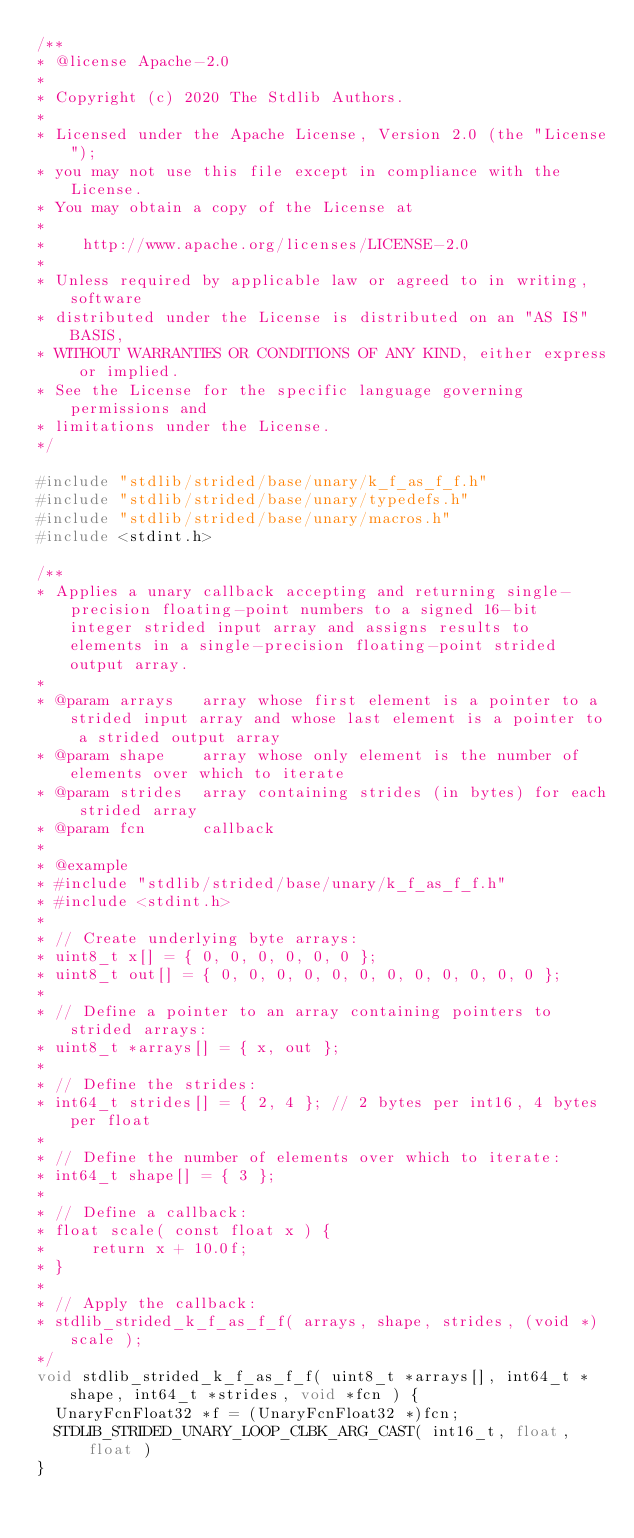<code> <loc_0><loc_0><loc_500><loc_500><_C_>/**
* @license Apache-2.0
*
* Copyright (c) 2020 The Stdlib Authors.
*
* Licensed under the Apache License, Version 2.0 (the "License");
* you may not use this file except in compliance with the License.
* You may obtain a copy of the License at
*
*    http://www.apache.org/licenses/LICENSE-2.0
*
* Unless required by applicable law or agreed to in writing, software
* distributed under the License is distributed on an "AS IS" BASIS,
* WITHOUT WARRANTIES OR CONDITIONS OF ANY KIND, either express or implied.
* See the License for the specific language governing permissions and
* limitations under the License.
*/

#include "stdlib/strided/base/unary/k_f_as_f_f.h"
#include "stdlib/strided/base/unary/typedefs.h"
#include "stdlib/strided/base/unary/macros.h"
#include <stdint.h>

/**
* Applies a unary callback accepting and returning single-precision floating-point numbers to a signed 16-bit integer strided input array and assigns results to elements in a single-precision floating-point strided output array.
*
* @param arrays   array whose first element is a pointer to a strided input array and whose last element is a pointer to a strided output array
* @param shape    array whose only element is the number of elements over which to iterate
* @param strides  array containing strides (in bytes) for each strided array
* @param fcn      callback
*
* @example
* #include "stdlib/strided/base/unary/k_f_as_f_f.h"
* #include <stdint.h>
*
* // Create underlying byte arrays:
* uint8_t x[] = { 0, 0, 0, 0, 0, 0 };
* uint8_t out[] = { 0, 0, 0, 0, 0, 0, 0, 0, 0, 0, 0, 0 };
*
* // Define a pointer to an array containing pointers to strided arrays:
* uint8_t *arrays[] = { x, out };
*
* // Define the strides:
* int64_t strides[] = { 2, 4 }; // 2 bytes per int16, 4 bytes per float
*
* // Define the number of elements over which to iterate:
* int64_t shape[] = { 3 };
*
* // Define a callback:
* float scale( const float x ) {
*     return x + 10.0f;
* }
*
* // Apply the callback:
* stdlib_strided_k_f_as_f_f( arrays, shape, strides, (void *)scale );
*/
void stdlib_strided_k_f_as_f_f( uint8_t *arrays[], int64_t *shape, int64_t *strides, void *fcn ) {
	UnaryFcnFloat32 *f = (UnaryFcnFloat32 *)fcn;
	STDLIB_STRIDED_UNARY_LOOP_CLBK_ARG_CAST( int16_t, float, float )
}
</code> 